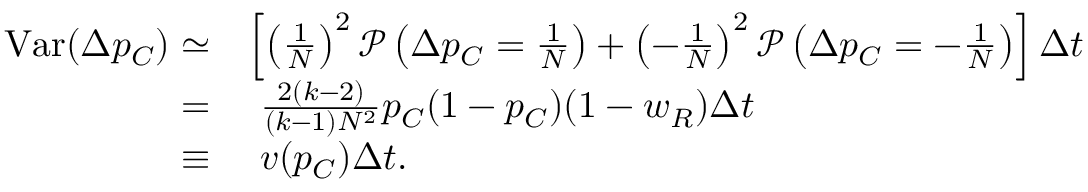<formula> <loc_0><loc_0><loc_500><loc_500>\begin{array} { r l } { V a r ( \Delta p _ { C } ) \simeq } & { \left [ \left ( \frac { 1 } { N } \right ) ^ { 2 } \mathcal { P } \left ( \Delta p _ { C } = \frac { 1 } { N } \right ) + \left ( - \frac { 1 } { N } \right ) ^ { 2 } \mathcal { P } \left ( \Delta p _ { C } = - \frac { 1 } { N } \right ) \right ] \Delta t } \\ { = } & { \frac { 2 ( k - 2 ) } { ( k - 1 ) N ^ { 2 } } p _ { C } ( 1 - p _ { C } ) ( 1 - w _ { R } ) \Delta t } \\ { \equiv } & { v ( p _ { C } ) \Delta t . } \end{array}</formula> 